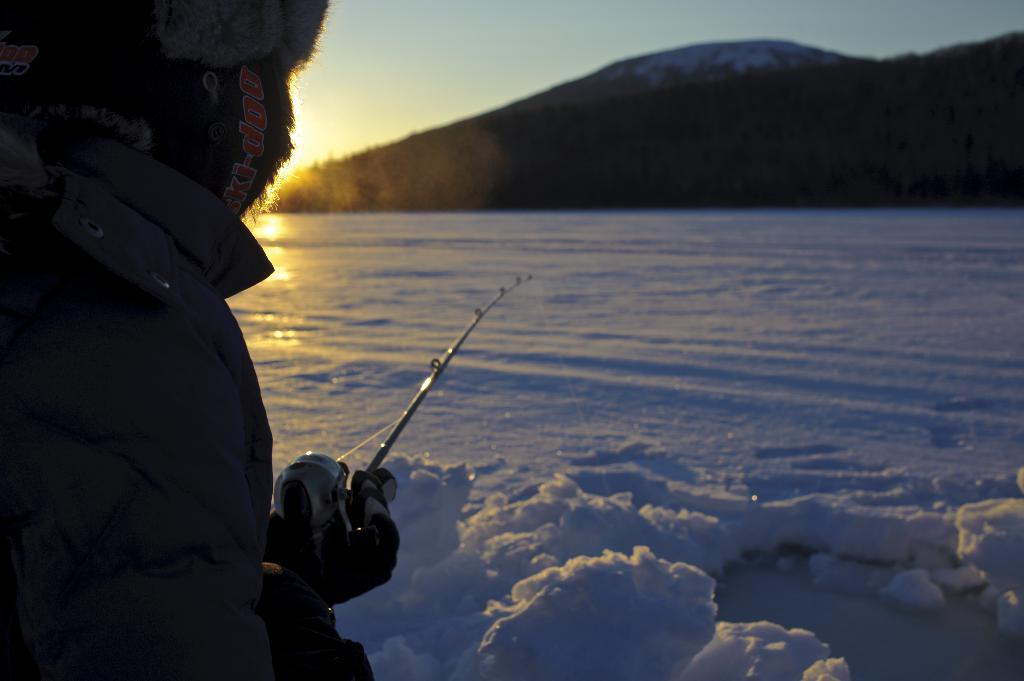What can be seen in the image? There is a person in the image. What is the person wearing? The person is wearing a coat. What is the person holding? The person is holding a stick. What can be seen in the background of the image? There are hills and trees in the background of the image. What is the ground condition at the bottom of the image? There is snow at the bottom of the image. Can you see any butter on the person's coat in the image? There is no butter present in the image. Is there a basketball game happening in the background of the image? There is no basketball game or any reference to a basketball in the image. 